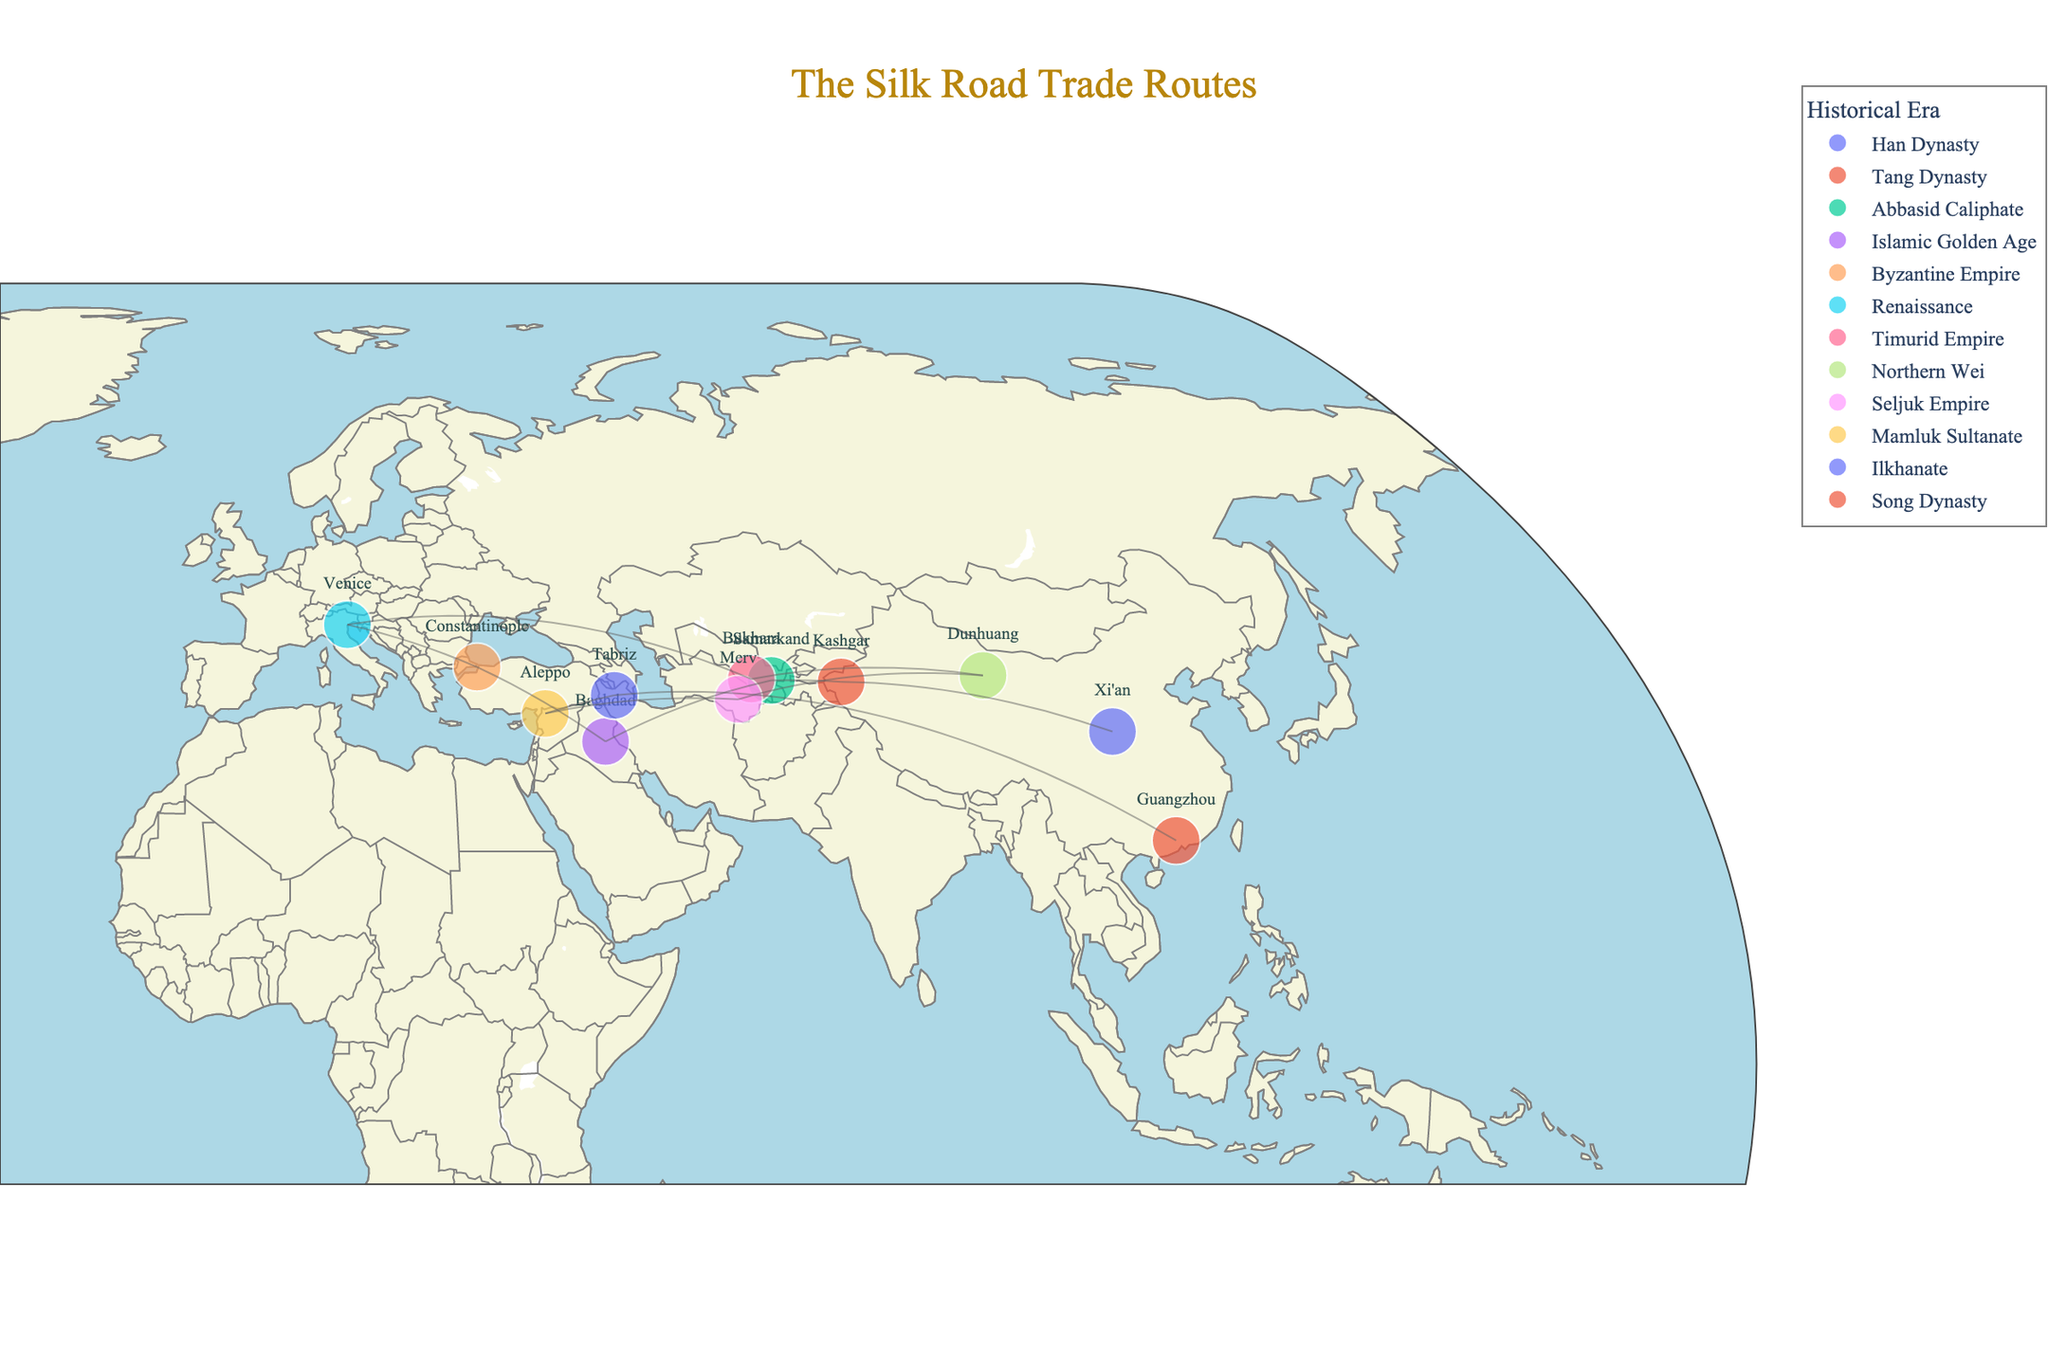What is the title of the figure? The title is found at the top center of the map. It is written in an Old Standard TT font in dark goldenrod color.
Answer: The Silk Road Trade Routes How many cities are marked along the Silk Road? Look at the number of points marked on the map with city names next to them. Count all such points.
Answer: 12 Which city is noted for trading silk? Move your cursor over the points to view the hover information or read the city names and their commodities listed on the map. Find the city associated with silk.
Answer: Xi'an Which two cities are closest to each other? Visually compare the distances between all pairs of cities on the map and identify the pair with the least distance between them.
Answer: Aleppo and Baghdad What commodity was traded in Venice? Hover over Venice on the map and observe the commodity listed in the hover information.
Answer: Glass Which historical era is represented by the highest number of cities? Look at the legend for the historical eras and count the number of cities belonging to each era. Identify the era with the most cities.
Answer: Tang Dynasty List all the cities that were important during the Song Dynasty. Find the historical era "Song Dynasty" in the legend, trace the corresponding points on the map and list their names.
Answer: Guangzhou What is the farthest city to the west on the Silk Road? Locate the westernmost point (longitude) on the map and identify the city.
Answer: Venice What commodities were traded between Baghdad and Constantinople? Locate Baghdad and Constantinople on the map and check the commodities listed next to these cities.
Answer: Spices and Gold How does the trade route visually appear on the map? Observe the way the route lines are drawn between cities on the map, especially the color and width of these lines.
Answer: Lines in gray color with slight transparency 